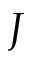Convert formula to latex. <formula><loc_0><loc_0><loc_500><loc_500>J</formula> 